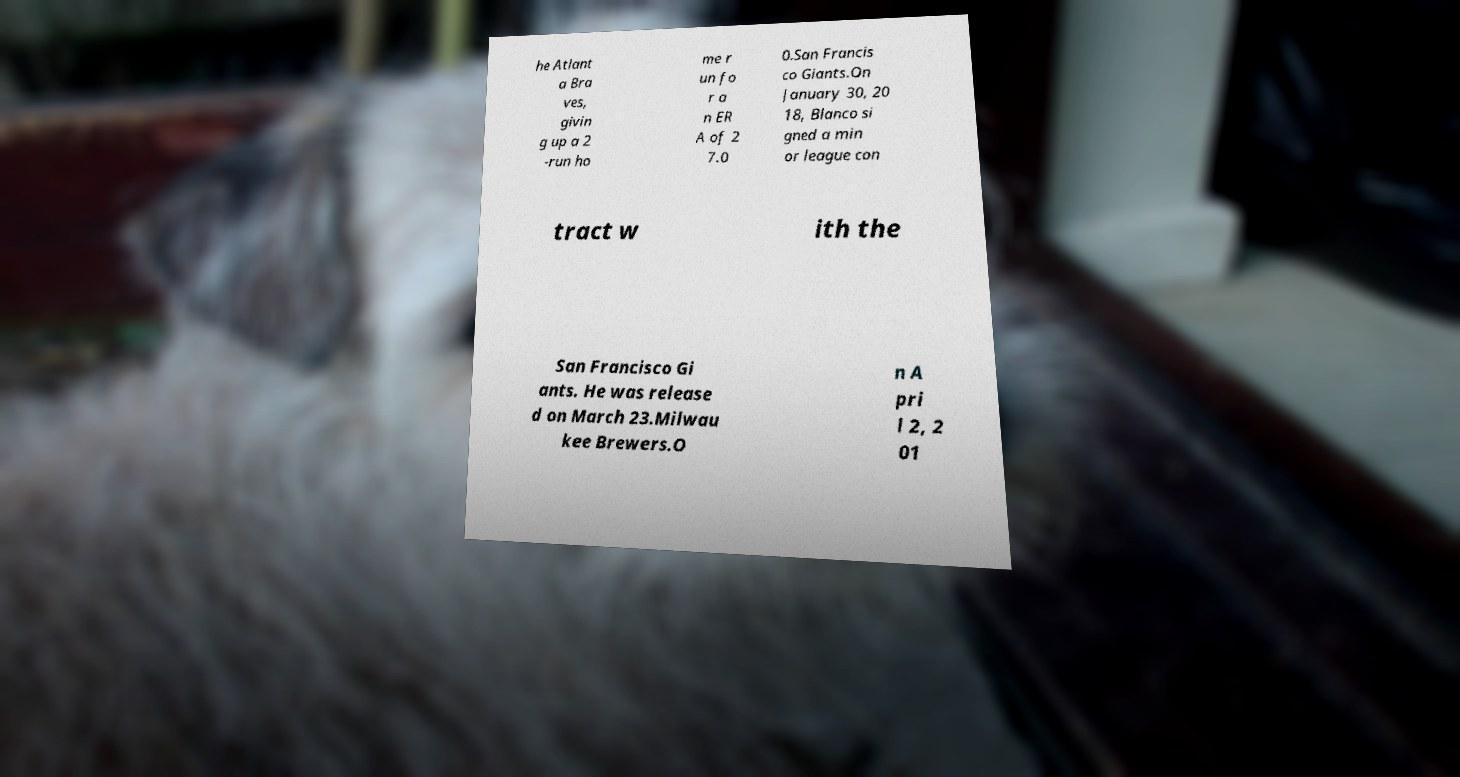Could you extract and type out the text from this image? he Atlant a Bra ves, givin g up a 2 -run ho me r un fo r a n ER A of 2 7.0 0.San Francis co Giants.On January 30, 20 18, Blanco si gned a min or league con tract w ith the San Francisco Gi ants. He was release d on March 23.Milwau kee Brewers.O n A pri l 2, 2 01 